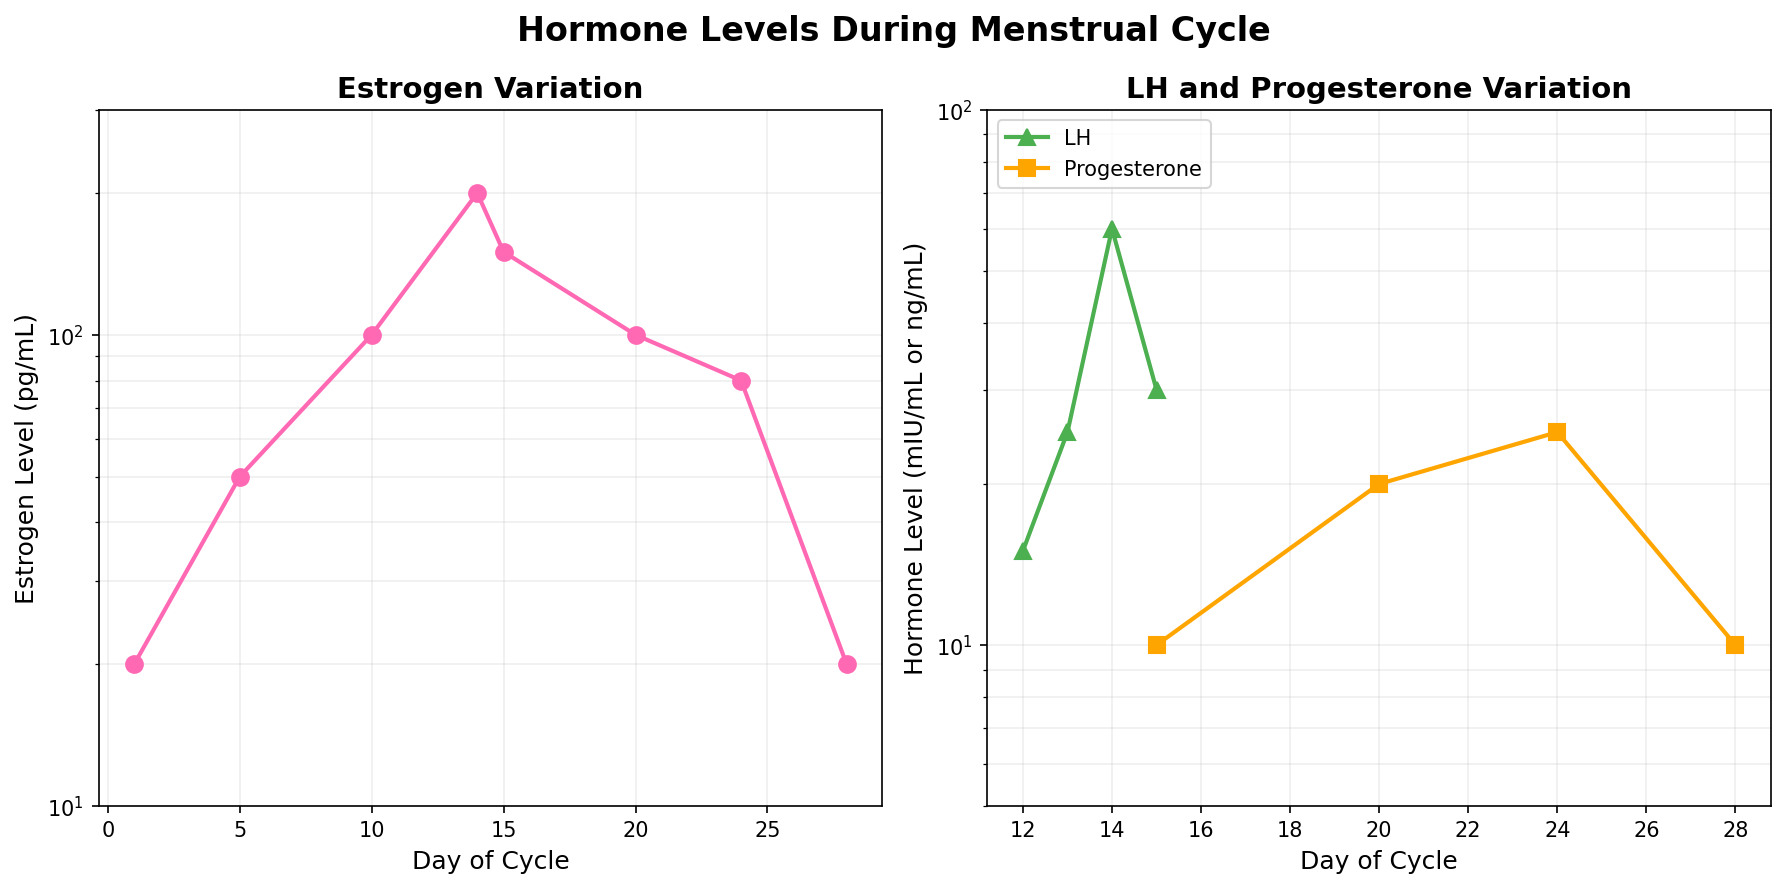What is the title of the figure? The title of the figure is mentioned at the top in bold and larger font compared to other text elements. The title provides a summary of what the figure represents.
Answer: Hormone Levels During Menstrual Cycle Which hormone shows the highest peak during the Ovulation stage? The LH hormone, depicted in green, shows a sharp spike around day 14, reaching its highest level during the ovulation stage.
Answer: LH How many data points are plotted for estrogen in the follicular phase? To find how many data points are plotted for estrogen in the follicular phase, we need to check the pink line in the Estrogen plot (left sub-plot), marking each data point.
Answer: 4 What is the general trend of progesterone levels during the luteal phase? The progesterone levels, indicated by the orange line in the LH and Progesterone plot (right sub-plot), show a rise from day 15 to day 24 and then a drop at day 28.
Answer: Rise and then drop How does the peak level of LH during ovulation compare to the peak level of Estrogen during the follicular phase? The LH peak level during ovulation (60 mIU/mL) is indicated by the green line on the right plot. The Estrogen peak level during the follicular phase (200 pg/mL) is shown on the left plot in pink. Comparatively, 60 is less than 200.
Answer: LH peak is less than Estrogen peak What is the estrogen level on day 24 of the menstrual cycle? The estrogen level on day 24 is found on the pink line in the Estrogen plot (left sub-plot). On day 24, the estrogen level is marked at 80 pg/mL.
Answer: 80 pg/mL Which hormone shows a decline between day 24 and day 28? By observing the trends on both the plots, the estrogen level line (pink) in the Estrogen plot (left plot) and the progesterone level line (orange) in the LH and Progesterone plot (right plot) both show a decline between day 24 and day 28.
Answer: Estrogen and Progesterone During which phase is the variability in estrogen levels the highest? The variance in estrogen levels can be observed by looking at the steepest slope or largest difference in levels. The follicular phase in the Estrogen plot (left sub-plot) shows a significant rise, indicating high variability.
Answer: Follicular phase Between which days does the LH hormone show its fastest increase? By examining the slope of the green line in the LH and Progesterone plot (right sub-plot), the steepest increase for the LH hormone occurs between days 13 and 14.
Answer: Days 13 and 14 